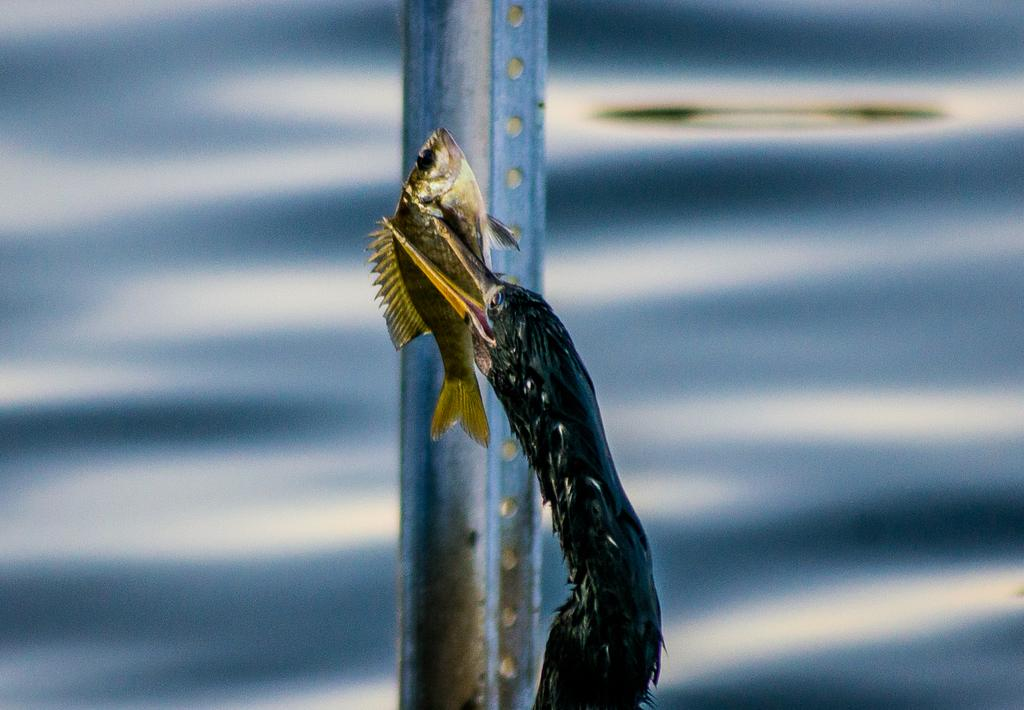What type of animal can be seen in the image? There is an animal in the image, but the specific type cannot be determined from the provided facts. What is the animal doing in the image? The animal is holding a fish in its mouth. Can you describe the background of the image? The background of the image is blurred. What color is the dog's eye in the image? There is no dog present in the image, and therefore no eye to describe. 